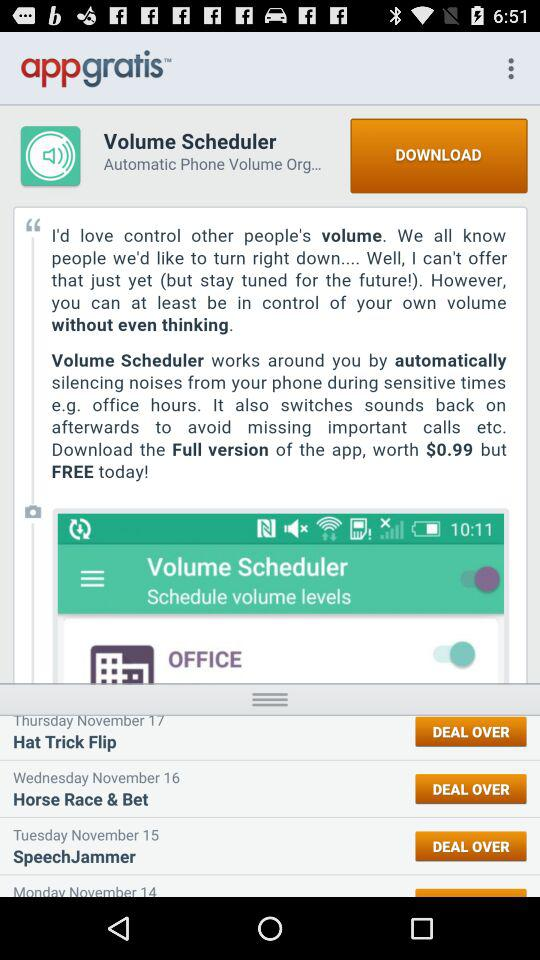How many days are in the schedule?
Answer the question using a single word or phrase. 4 